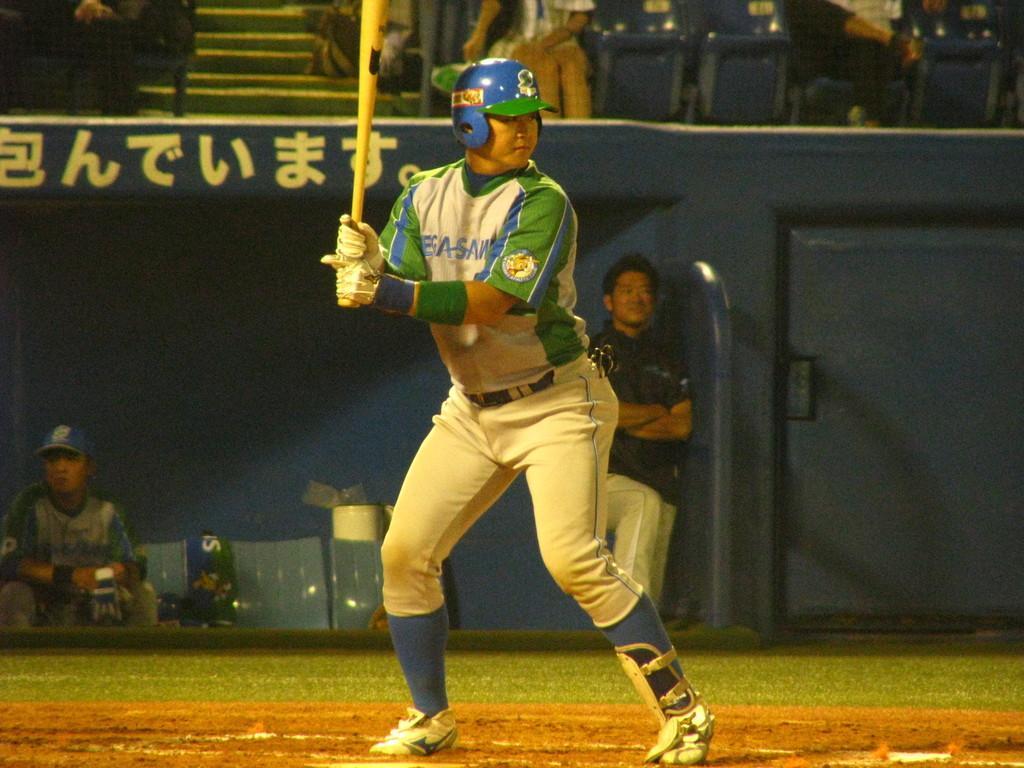Please provide a concise description of this image. In this image we can see a man is standing on the playground. He is holding a baseball bat in his hand and wearing white-green color dress, white gloves and blue helmet. Behind the man, we can see one man, chairs and poster. We can see one more man is sitting on the chair on the left side of the image. At the top of the image, we can see people are sitting on the chairs. 